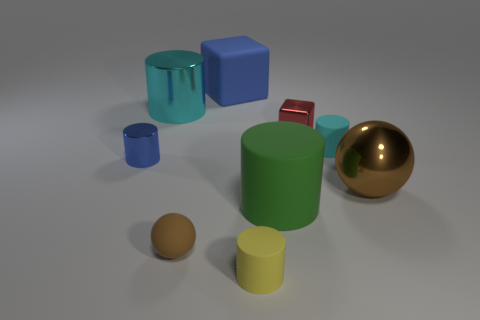Subtract 2 cylinders. How many cylinders are left? 3 Subtract all green cylinders. How many cylinders are left? 4 Subtract all small metallic cylinders. How many cylinders are left? 4 Subtract all gray cylinders. Subtract all blue balls. How many cylinders are left? 5 Subtract all cylinders. How many objects are left? 4 Subtract all cyan shiny cylinders. Subtract all small red blocks. How many objects are left? 7 Add 7 tiny shiny objects. How many tiny shiny objects are left? 9 Add 9 tiny purple cylinders. How many tiny purple cylinders exist? 9 Subtract 0 yellow blocks. How many objects are left? 9 